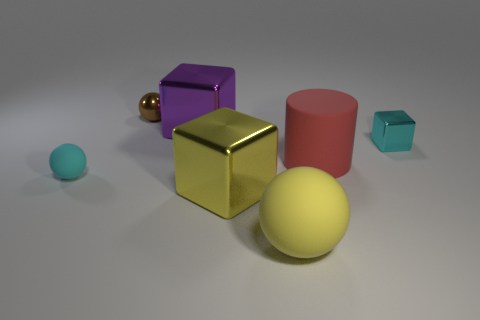Subtract all rubber balls. How many balls are left? 1 Add 2 small cyan objects. How many objects exist? 9 Subtract all yellow cubes. How many cubes are left? 2 Subtract 2 blocks. How many blocks are left? 1 Add 4 large red rubber objects. How many large red rubber objects are left? 5 Add 7 purple blocks. How many purple blocks exist? 8 Subtract 1 yellow balls. How many objects are left? 6 Subtract all cylinders. How many objects are left? 6 Subtract all red blocks. Subtract all cyan cylinders. How many blocks are left? 3 Subtract all large metal objects. Subtract all big yellow balls. How many objects are left? 4 